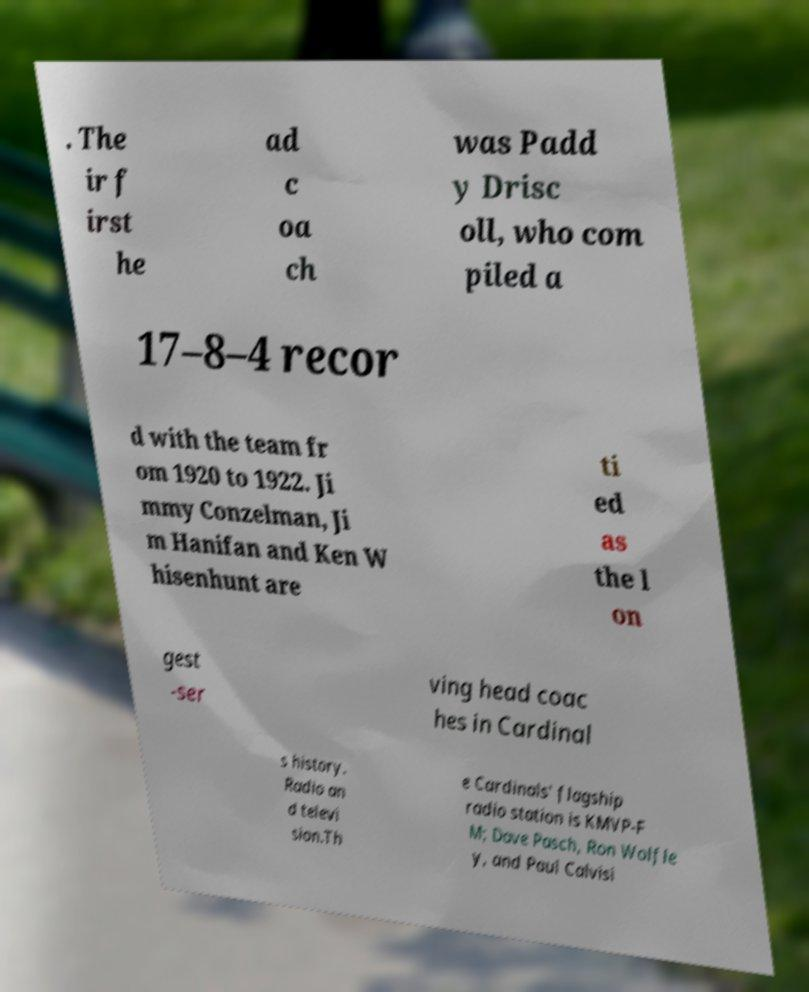Can you accurately transcribe the text from the provided image for me? . The ir f irst he ad c oa ch was Padd y Drisc oll, who com piled a 17–8–4 recor d with the team fr om 1920 to 1922. Ji mmy Conzelman, Ji m Hanifan and Ken W hisenhunt are ti ed as the l on gest -ser ving head coac hes in Cardinal s history. Radio an d televi sion.Th e Cardinals' flagship radio station is KMVP-F M; Dave Pasch, Ron Wolfle y, and Paul Calvisi 